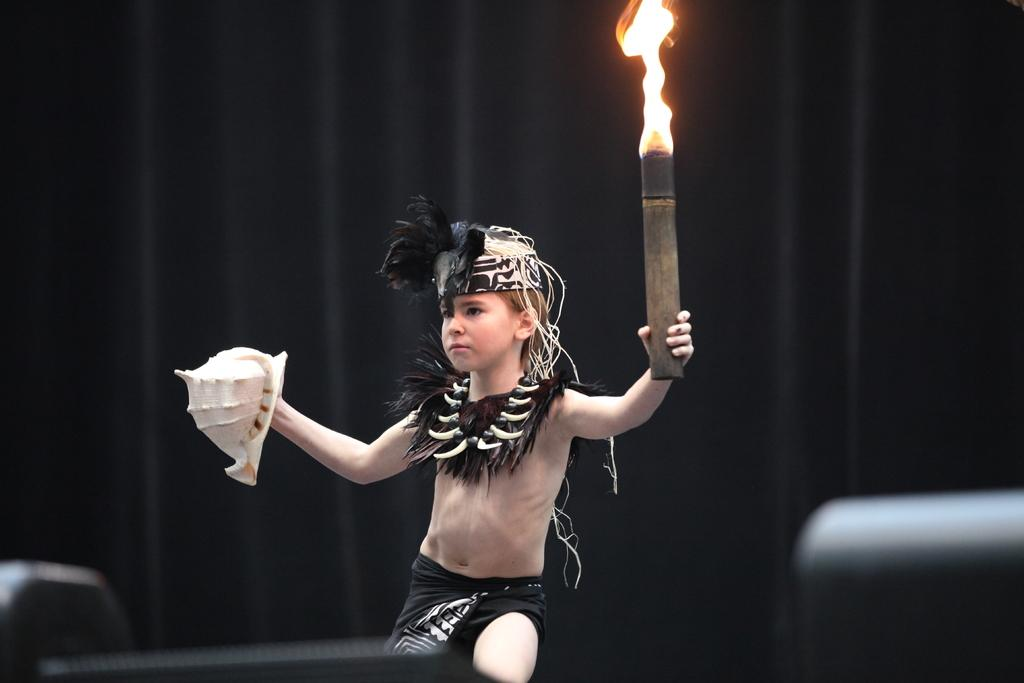What is the main subject of the picture? The main subject of the picture is a child. What is the child doing in the image? The child is holding some objects. Can you describe the background of the image? The background of the image is blurred. What can be seen on the bottom left and right side of the picture? There are objects on the bottom left and right side of the picture. What language is the child speaking in the image? There is no indication of the child speaking in the image, so it cannot be determined from the picture. Can you see a turkey in the image? There is no turkey present in the image. 